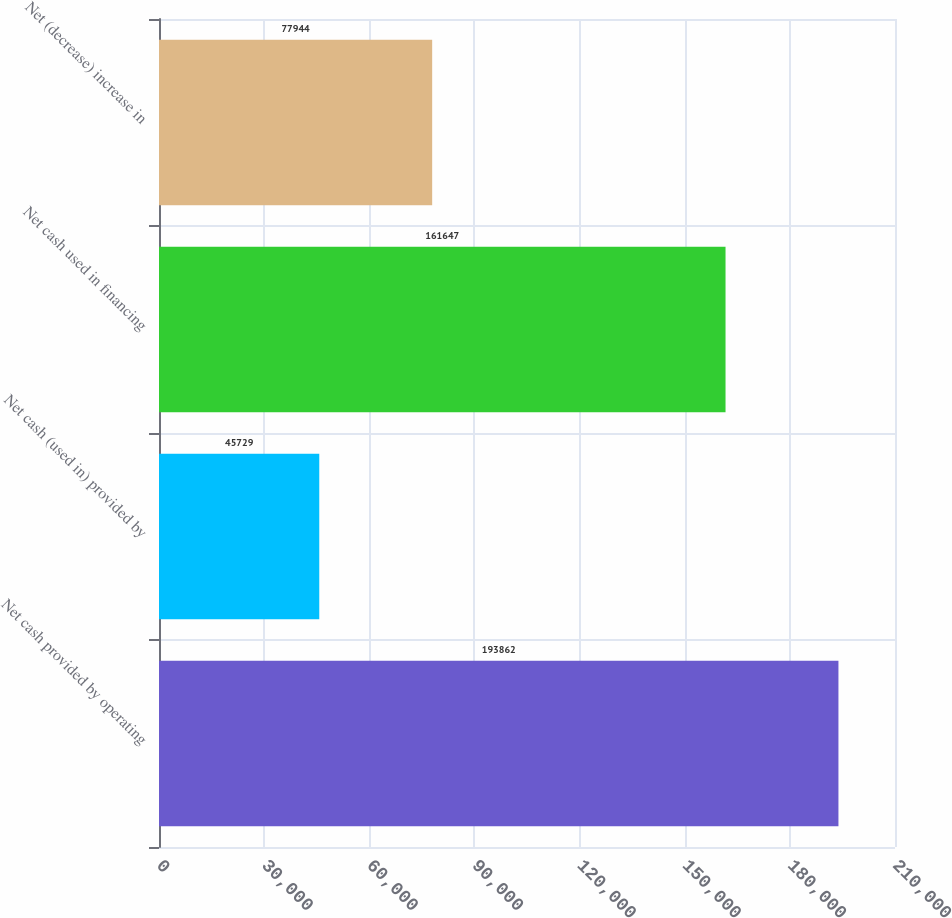<chart> <loc_0><loc_0><loc_500><loc_500><bar_chart><fcel>Net cash provided by operating<fcel>Net cash (used in) provided by<fcel>Net cash used in financing<fcel>Net (decrease) increase in<nl><fcel>193862<fcel>45729<fcel>161647<fcel>77944<nl></chart> 